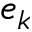Convert formula to latex. <formula><loc_0><loc_0><loc_500><loc_500>e _ { k }</formula> 